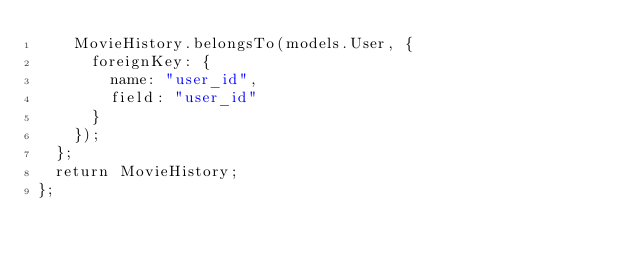<code> <loc_0><loc_0><loc_500><loc_500><_JavaScript_>    MovieHistory.belongsTo(models.User, {
      foreignKey: {
        name: "user_id",
        field: "user_id"
      }
    });
  };
  return MovieHistory;
};
</code> 